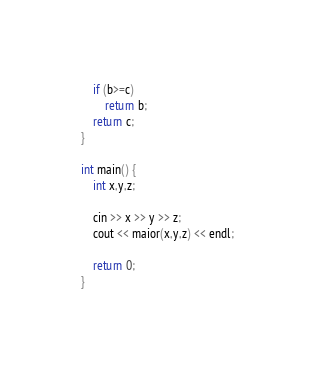<code> <loc_0><loc_0><loc_500><loc_500><_C++_>	if (b>=c)
		return b;
	return c;
}

int main() {
	int x,y,z;
	
	cin >> x >> y >> z;
	cout << maior(x,y,z) << endl;
	
	return 0;
}








</code> 